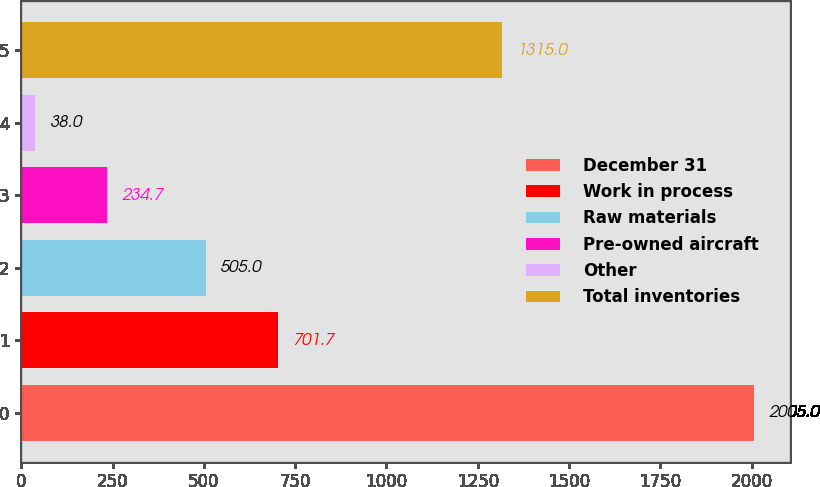<chart> <loc_0><loc_0><loc_500><loc_500><bar_chart><fcel>December 31<fcel>Work in process<fcel>Raw materials<fcel>Pre-owned aircraft<fcel>Other<fcel>Total inventories<nl><fcel>2005<fcel>701.7<fcel>505<fcel>234.7<fcel>38<fcel>1315<nl></chart> 